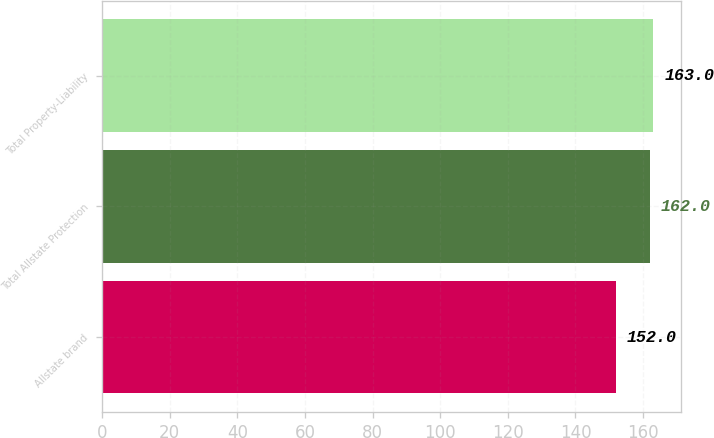Convert chart to OTSL. <chart><loc_0><loc_0><loc_500><loc_500><bar_chart><fcel>Allstate brand<fcel>Total Allstate Protection<fcel>Total Property-Liability<nl><fcel>152<fcel>162<fcel>163<nl></chart> 